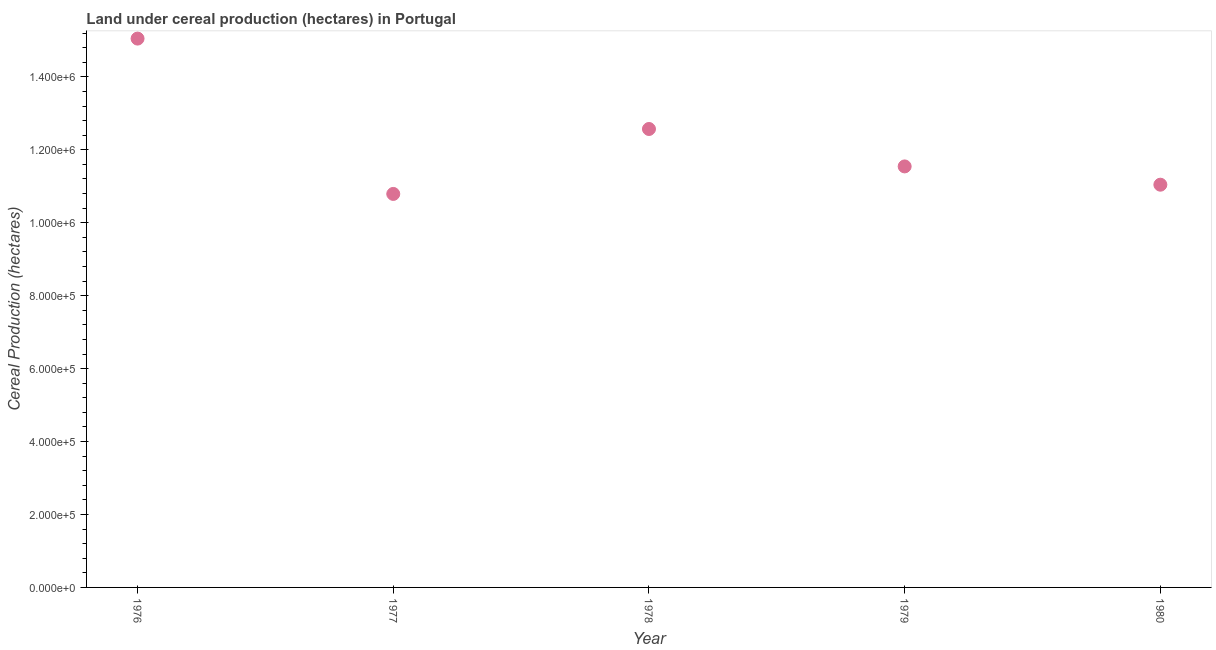What is the land under cereal production in 1978?
Provide a short and direct response. 1.26e+06. Across all years, what is the maximum land under cereal production?
Offer a terse response. 1.50e+06. Across all years, what is the minimum land under cereal production?
Ensure brevity in your answer.  1.08e+06. In which year was the land under cereal production maximum?
Give a very brief answer. 1976. What is the sum of the land under cereal production?
Provide a short and direct response. 6.10e+06. What is the difference between the land under cereal production in 1978 and 1980?
Your response must be concise. 1.53e+05. What is the average land under cereal production per year?
Offer a very short reply. 1.22e+06. What is the median land under cereal production?
Offer a very short reply. 1.15e+06. In how many years, is the land under cereal production greater than 1200000 hectares?
Offer a very short reply. 2. What is the ratio of the land under cereal production in 1977 to that in 1980?
Provide a succinct answer. 0.98. Is the land under cereal production in 1978 less than that in 1979?
Offer a terse response. No. Is the difference between the land under cereal production in 1978 and 1980 greater than the difference between any two years?
Make the answer very short. No. What is the difference between the highest and the second highest land under cereal production?
Ensure brevity in your answer.  2.48e+05. What is the difference between the highest and the lowest land under cereal production?
Your answer should be very brief. 4.26e+05. How many dotlines are there?
Your answer should be very brief. 1. What is the difference between two consecutive major ticks on the Y-axis?
Ensure brevity in your answer.  2.00e+05. Are the values on the major ticks of Y-axis written in scientific E-notation?
Give a very brief answer. Yes. Does the graph contain grids?
Offer a very short reply. No. What is the title of the graph?
Provide a short and direct response. Land under cereal production (hectares) in Portugal. What is the label or title of the X-axis?
Offer a terse response. Year. What is the label or title of the Y-axis?
Offer a very short reply. Cereal Production (hectares). What is the Cereal Production (hectares) in 1976?
Your answer should be very brief. 1.50e+06. What is the Cereal Production (hectares) in 1977?
Keep it short and to the point. 1.08e+06. What is the Cereal Production (hectares) in 1978?
Your answer should be very brief. 1.26e+06. What is the Cereal Production (hectares) in 1979?
Your answer should be compact. 1.15e+06. What is the Cereal Production (hectares) in 1980?
Keep it short and to the point. 1.10e+06. What is the difference between the Cereal Production (hectares) in 1976 and 1977?
Offer a very short reply. 4.26e+05. What is the difference between the Cereal Production (hectares) in 1976 and 1978?
Your answer should be very brief. 2.48e+05. What is the difference between the Cereal Production (hectares) in 1976 and 1979?
Ensure brevity in your answer.  3.50e+05. What is the difference between the Cereal Production (hectares) in 1976 and 1980?
Give a very brief answer. 4.01e+05. What is the difference between the Cereal Production (hectares) in 1977 and 1978?
Your response must be concise. -1.78e+05. What is the difference between the Cereal Production (hectares) in 1977 and 1979?
Give a very brief answer. -7.54e+04. What is the difference between the Cereal Production (hectares) in 1977 and 1980?
Give a very brief answer. -2.53e+04. What is the difference between the Cereal Production (hectares) in 1978 and 1979?
Give a very brief answer. 1.03e+05. What is the difference between the Cereal Production (hectares) in 1978 and 1980?
Offer a terse response. 1.53e+05. What is the difference between the Cereal Production (hectares) in 1979 and 1980?
Provide a short and direct response. 5.01e+04. What is the ratio of the Cereal Production (hectares) in 1976 to that in 1977?
Your response must be concise. 1.4. What is the ratio of the Cereal Production (hectares) in 1976 to that in 1978?
Keep it short and to the point. 1.2. What is the ratio of the Cereal Production (hectares) in 1976 to that in 1979?
Offer a very short reply. 1.3. What is the ratio of the Cereal Production (hectares) in 1976 to that in 1980?
Offer a very short reply. 1.36. What is the ratio of the Cereal Production (hectares) in 1977 to that in 1978?
Your answer should be very brief. 0.86. What is the ratio of the Cereal Production (hectares) in 1977 to that in 1979?
Ensure brevity in your answer.  0.94. What is the ratio of the Cereal Production (hectares) in 1977 to that in 1980?
Your answer should be compact. 0.98. What is the ratio of the Cereal Production (hectares) in 1978 to that in 1979?
Ensure brevity in your answer.  1.09. What is the ratio of the Cereal Production (hectares) in 1978 to that in 1980?
Offer a terse response. 1.14. What is the ratio of the Cereal Production (hectares) in 1979 to that in 1980?
Provide a succinct answer. 1.04. 